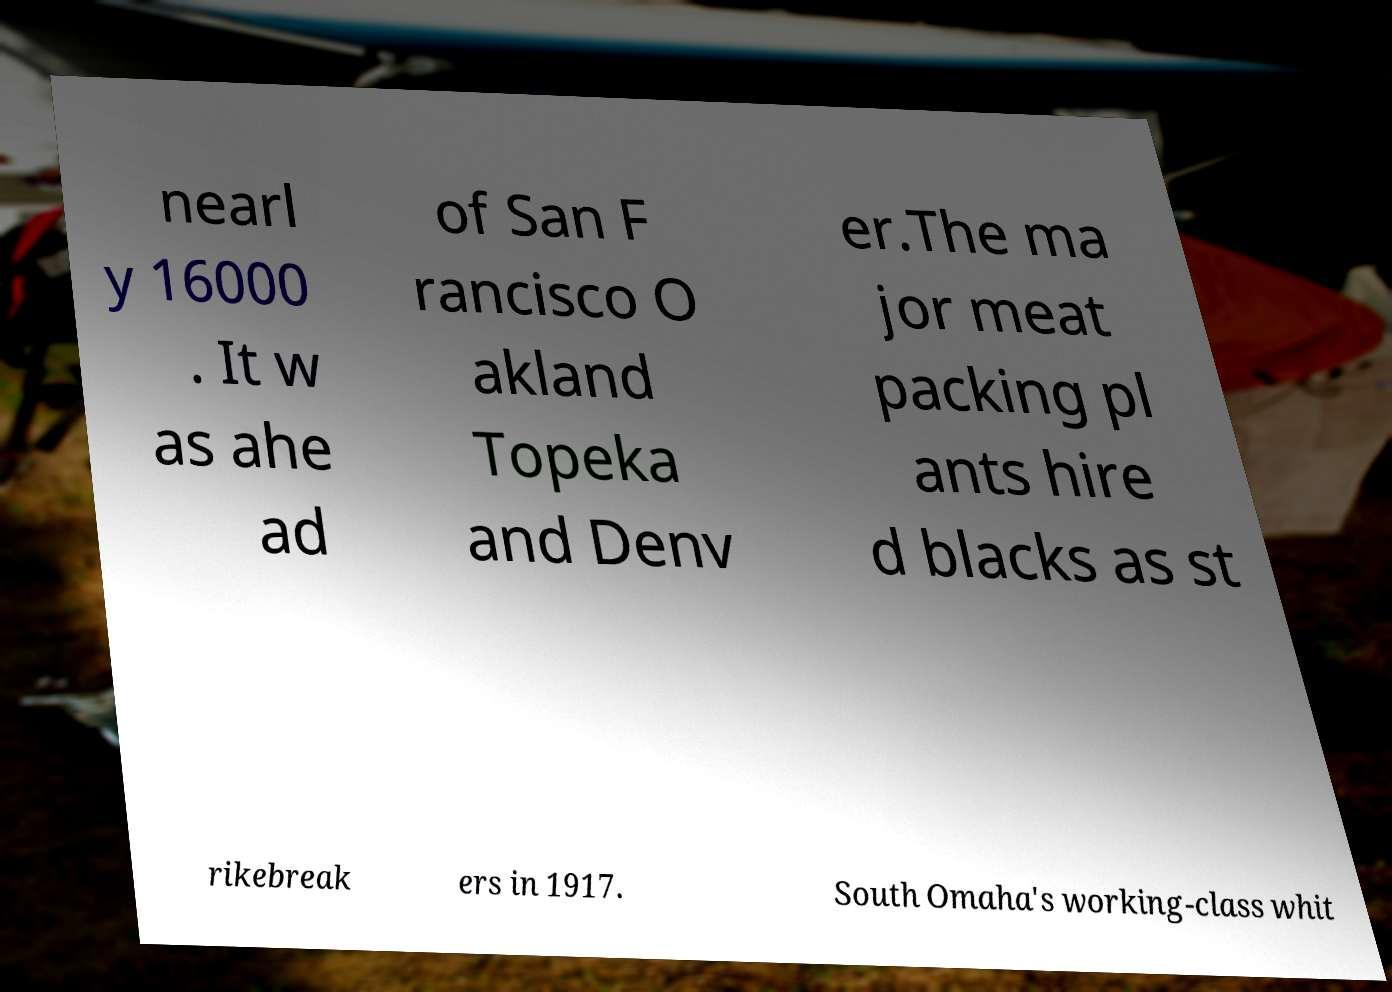Can you read and provide the text displayed in the image?This photo seems to have some interesting text. Can you extract and type it out for me? nearl y 16000 . It w as ahe ad of San F rancisco O akland Topeka and Denv er.The ma jor meat packing pl ants hire d blacks as st rikebreak ers in 1917. South Omaha's working-class whit 